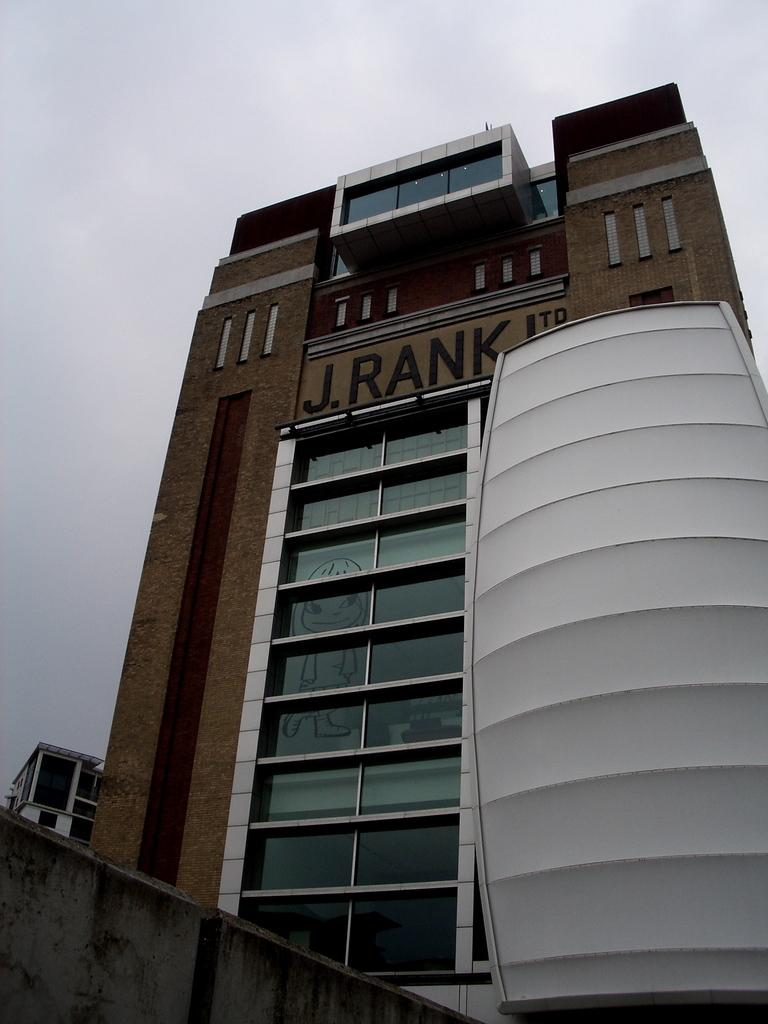What is the main structure in the image? There is a tall building in the image. What feature is prominent on the building? The building has many windows. What object is located near the building? There is a white color shield kept near the building. What can be seen in the background of the image? The sky is visible in the background of the image. What is the condition of the sneeze in the image? There is no sneeze present in the image. What company is responsible for the construction of the building in the image? The provided facts do not mention any company responsible for the construction of the building. 